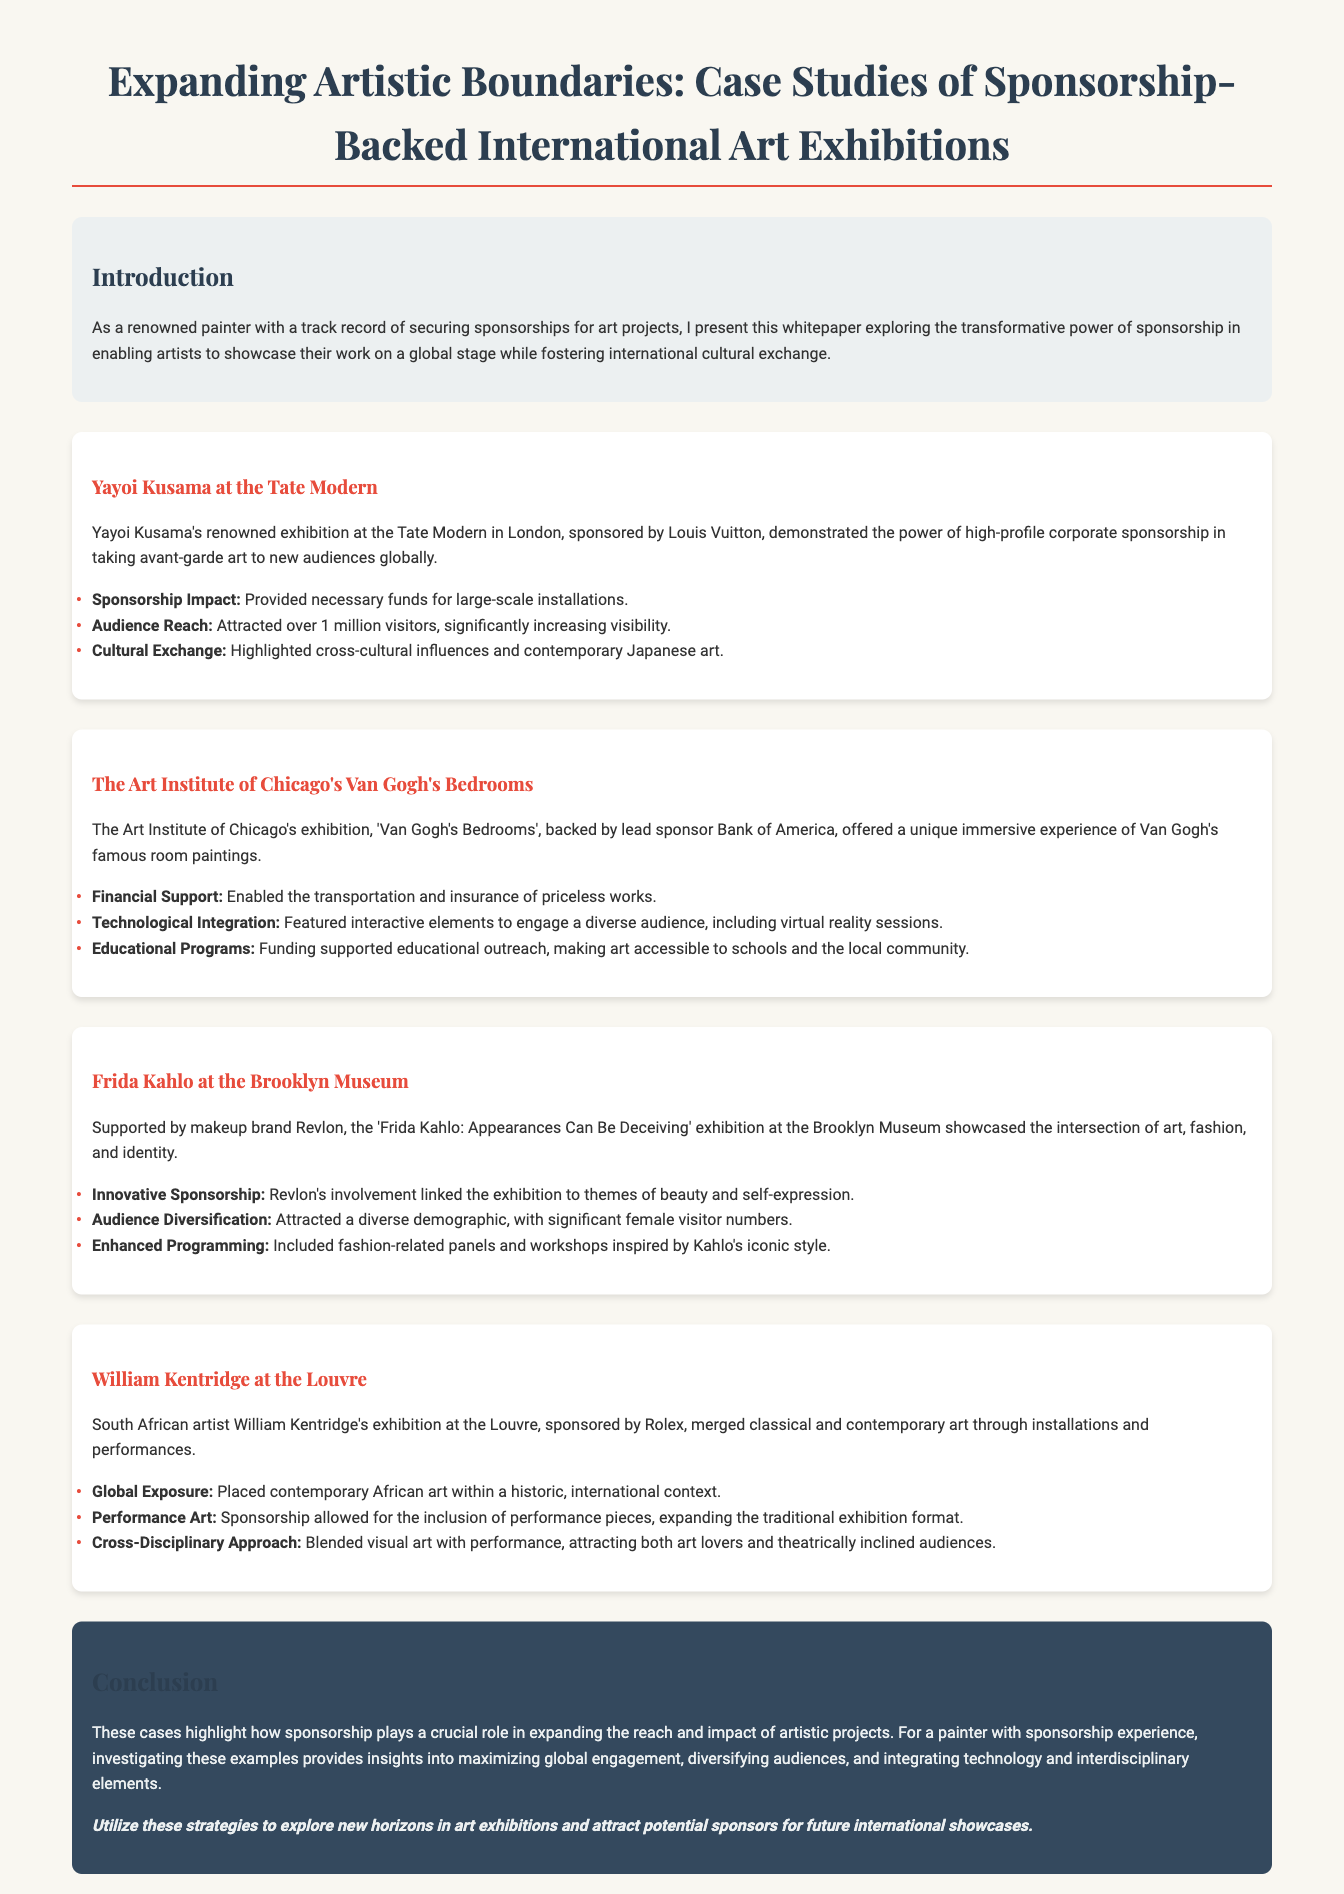What was the title of the exhibition at the Tate Modern? The exhibition title mentioned is Yayoi Kusama's exhibition at the Tate Modern.
Answer: Yayoi Kusama Who sponsored the Van Gogh's Bedrooms exhibition? The lead sponsor for the Van Gogh's Bedrooms exhibition at the Art Institute of Chicago is specified in the document as Bank of America.
Answer: Bank of America How many visitors did Yayoi Kusama's exhibition attract? The document states that it attracted over 1 million visitors, highlighting the audience reach.
Answer: Over 1 million What was a key theme of the Frida Kahlo exhibition? The document references the intersection of art, fashion, and identity as a key theme of the Frida Kahlo exhibition.
Answer: Art, fashion, and identity Which artist's work was featured at the Louvre? The document specifies that South African artist William Kentridge's work was featured in the exhibition at the Louvre.
Answer: William Kentridge What kind of support did the Van Gogh's Bedrooms exhibition receive for educational outreach? The document mentions that funding supported educational outreach to make art accessible to schools and the local community.
Answer: Educational outreach What is a notable feature of the William Kentridge exhibition? The inclusion of performance pieces is noted as an expansion of the traditional exhibition format.
Answer: Performance pieces What should painters investigate based on the conclusion? The document suggests that painters with sponsorship experience should investigate examples to maximize global engagement.
Answer: Global engagement 